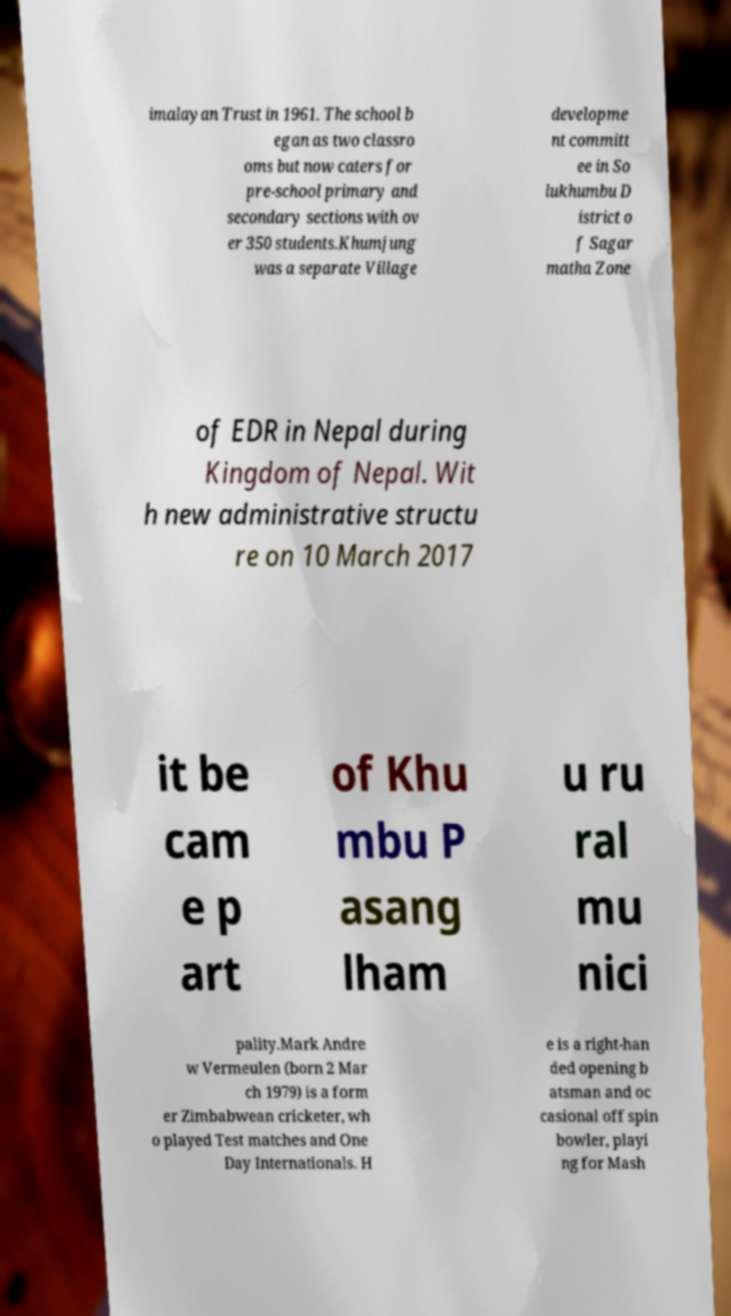What messages or text are displayed in this image? I need them in a readable, typed format. imalayan Trust in 1961. The school b egan as two classro oms but now caters for pre-school primary and secondary sections with ov er 350 students.Khumjung was a separate Village developme nt committ ee in So lukhumbu D istrict o f Sagar matha Zone of EDR in Nepal during Kingdom of Nepal. Wit h new administrative structu re on 10 March 2017 it be cam e p art of Khu mbu P asang lham u ru ral mu nici pality.Mark Andre w Vermeulen (born 2 Mar ch 1979) is a form er Zimbabwean cricketer, wh o played Test matches and One Day Internationals. H e is a right-han ded opening b atsman and oc casional off spin bowler, playi ng for Mash 